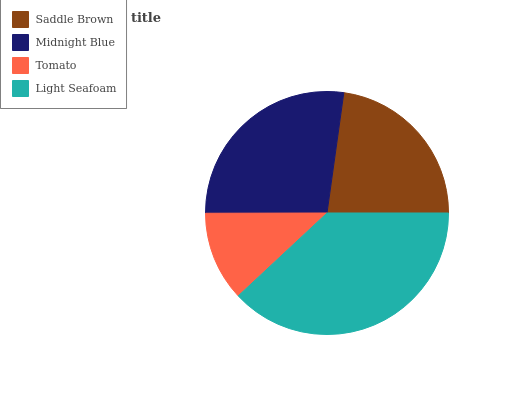Is Tomato the minimum?
Answer yes or no. Yes. Is Light Seafoam the maximum?
Answer yes or no. Yes. Is Midnight Blue the minimum?
Answer yes or no. No. Is Midnight Blue the maximum?
Answer yes or no. No. Is Midnight Blue greater than Saddle Brown?
Answer yes or no. Yes. Is Saddle Brown less than Midnight Blue?
Answer yes or no. Yes. Is Saddle Brown greater than Midnight Blue?
Answer yes or no. No. Is Midnight Blue less than Saddle Brown?
Answer yes or no. No. Is Midnight Blue the high median?
Answer yes or no. Yes. Is Saddle Brown the low median?
Answer yes or no. Yes. Is Light Seafoam the high median?
Answer yes or no. No. Is Light Seafoam the low median?
Answer yes or no. No. 